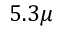Convert formula to latex. <formula><loc_0><loc_0><loc_500><loc_500>5 . 3 \mu</formula> 